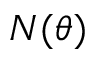Convert formula to latex. <formula><loc_0><loc_0><loc_500><loc_500>N ( \theta )</formula> 